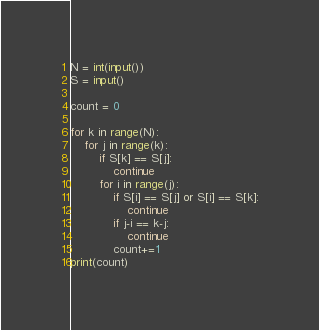<code> <loc_0><loc_0><loc_500><loc_500><_Python_>N = int(input())
S = input()

count = 0

for k in range(N):
    for j in range(k):
        if S[k] == S[j]:
            continue
        for i in range(j):
            if S[i] == S[j] or S[i] == S[k]:
                continue
            if j-i == k-j:
                continue
            count+=1
print(count)</code> 